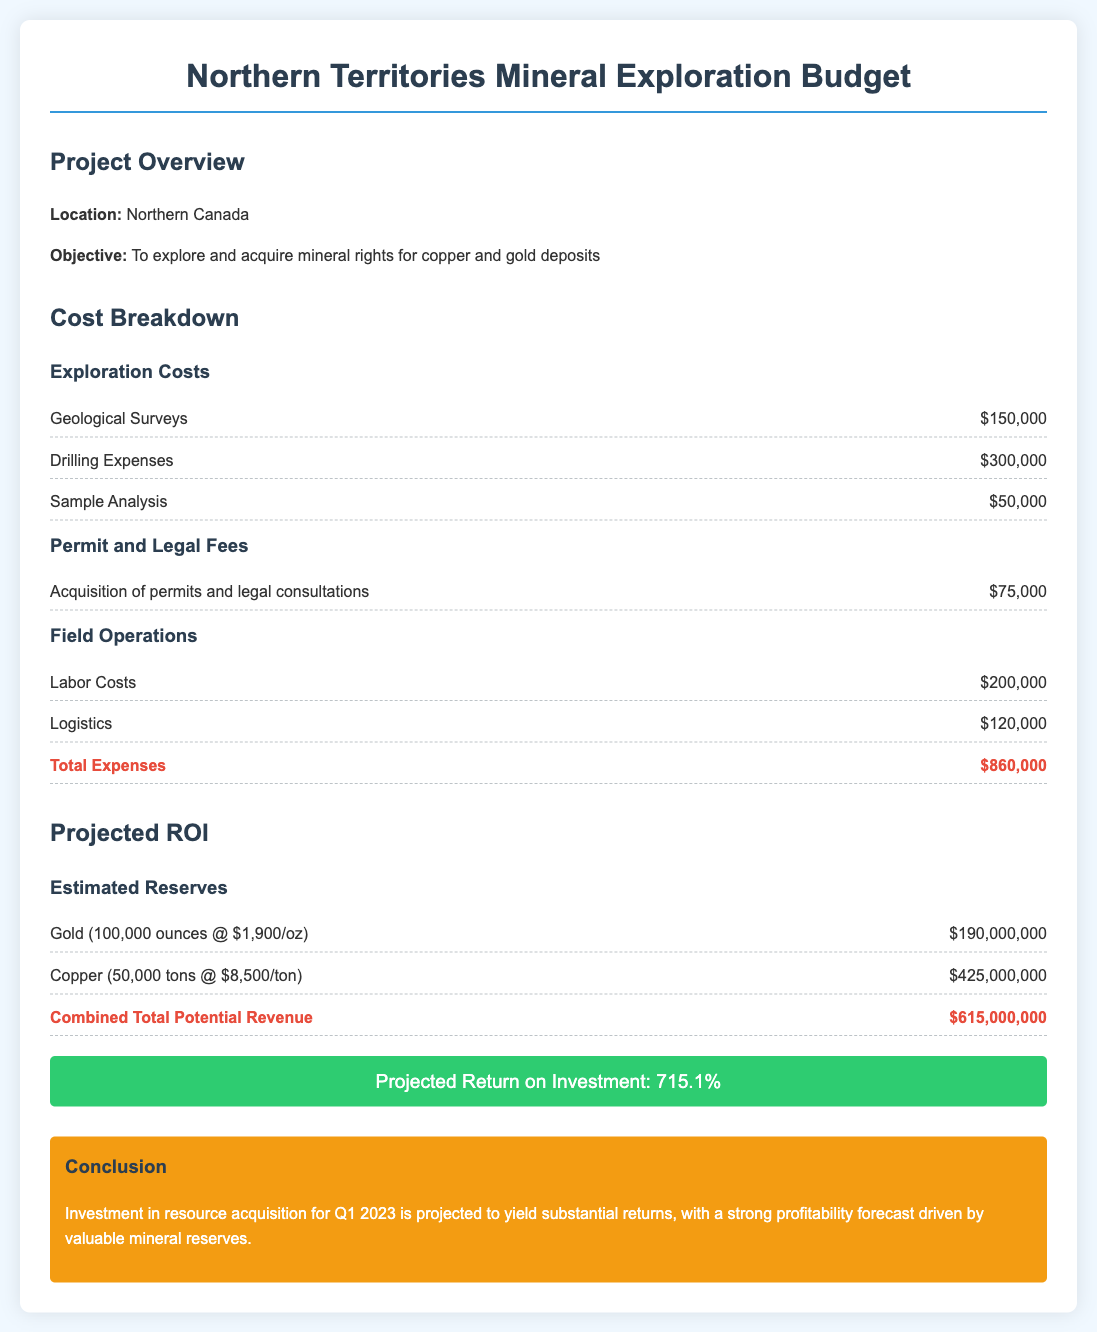What is the total exploration cost? The total exploration cost is the sum of Geological Surveys, Drilling Expenses, and Sample Analysis, which amounts to $150,000 + $300,000 + $50,000.
Answer: $500,000 What are the estimated reserves of gold? The estimated reserves of gold are given as 100,000 ounces at a price of $1,900 per ounce, which equals $190,000,000.
Answer: $190,000,000 What is the projected ROI percentage? The projected return on investment is stated directly in the document as 715.1%.
Answer: 715.1% How much is allocated for labor costs? The document specifies that Labor Costs are budgeted at $200,000.
Answer: $200,000 What is the total projected revenue from copper? The projected revenue from copper is calculated as 50,000 tons at $8,500 per ton, totaling $425,000,000.
Answer: $425,000,000 What is the total cost for permit and legal fees? The total cost for acquisition of permits and legal consultations amounts to $75,000.
Answer: $75,000 What is the total combined potential revenue? The combined total potential revenue is the sum of the projected revenues from gold and copper, which is $615,000,000.
Answer: $615,000,000 What is the total expenses amount? The total expenses are aggregately mentioned as $860,000.
Answer: $860,000 What is the objective of the project? The objective is to explore and acquire mineral rights for copper and gold deposits.
Answer: To explore and acquire mineral rights for copper and gold deposits 